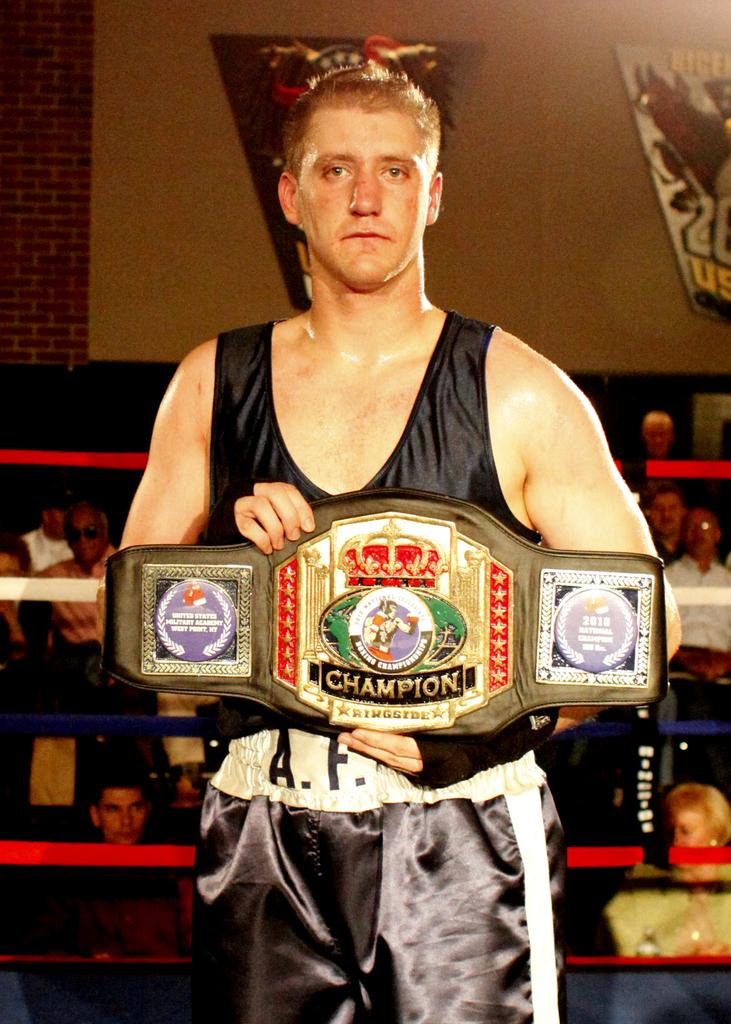<image>
Relay a brief, clear account of the picture shown. A wrestler holds a large belt that says champion. 